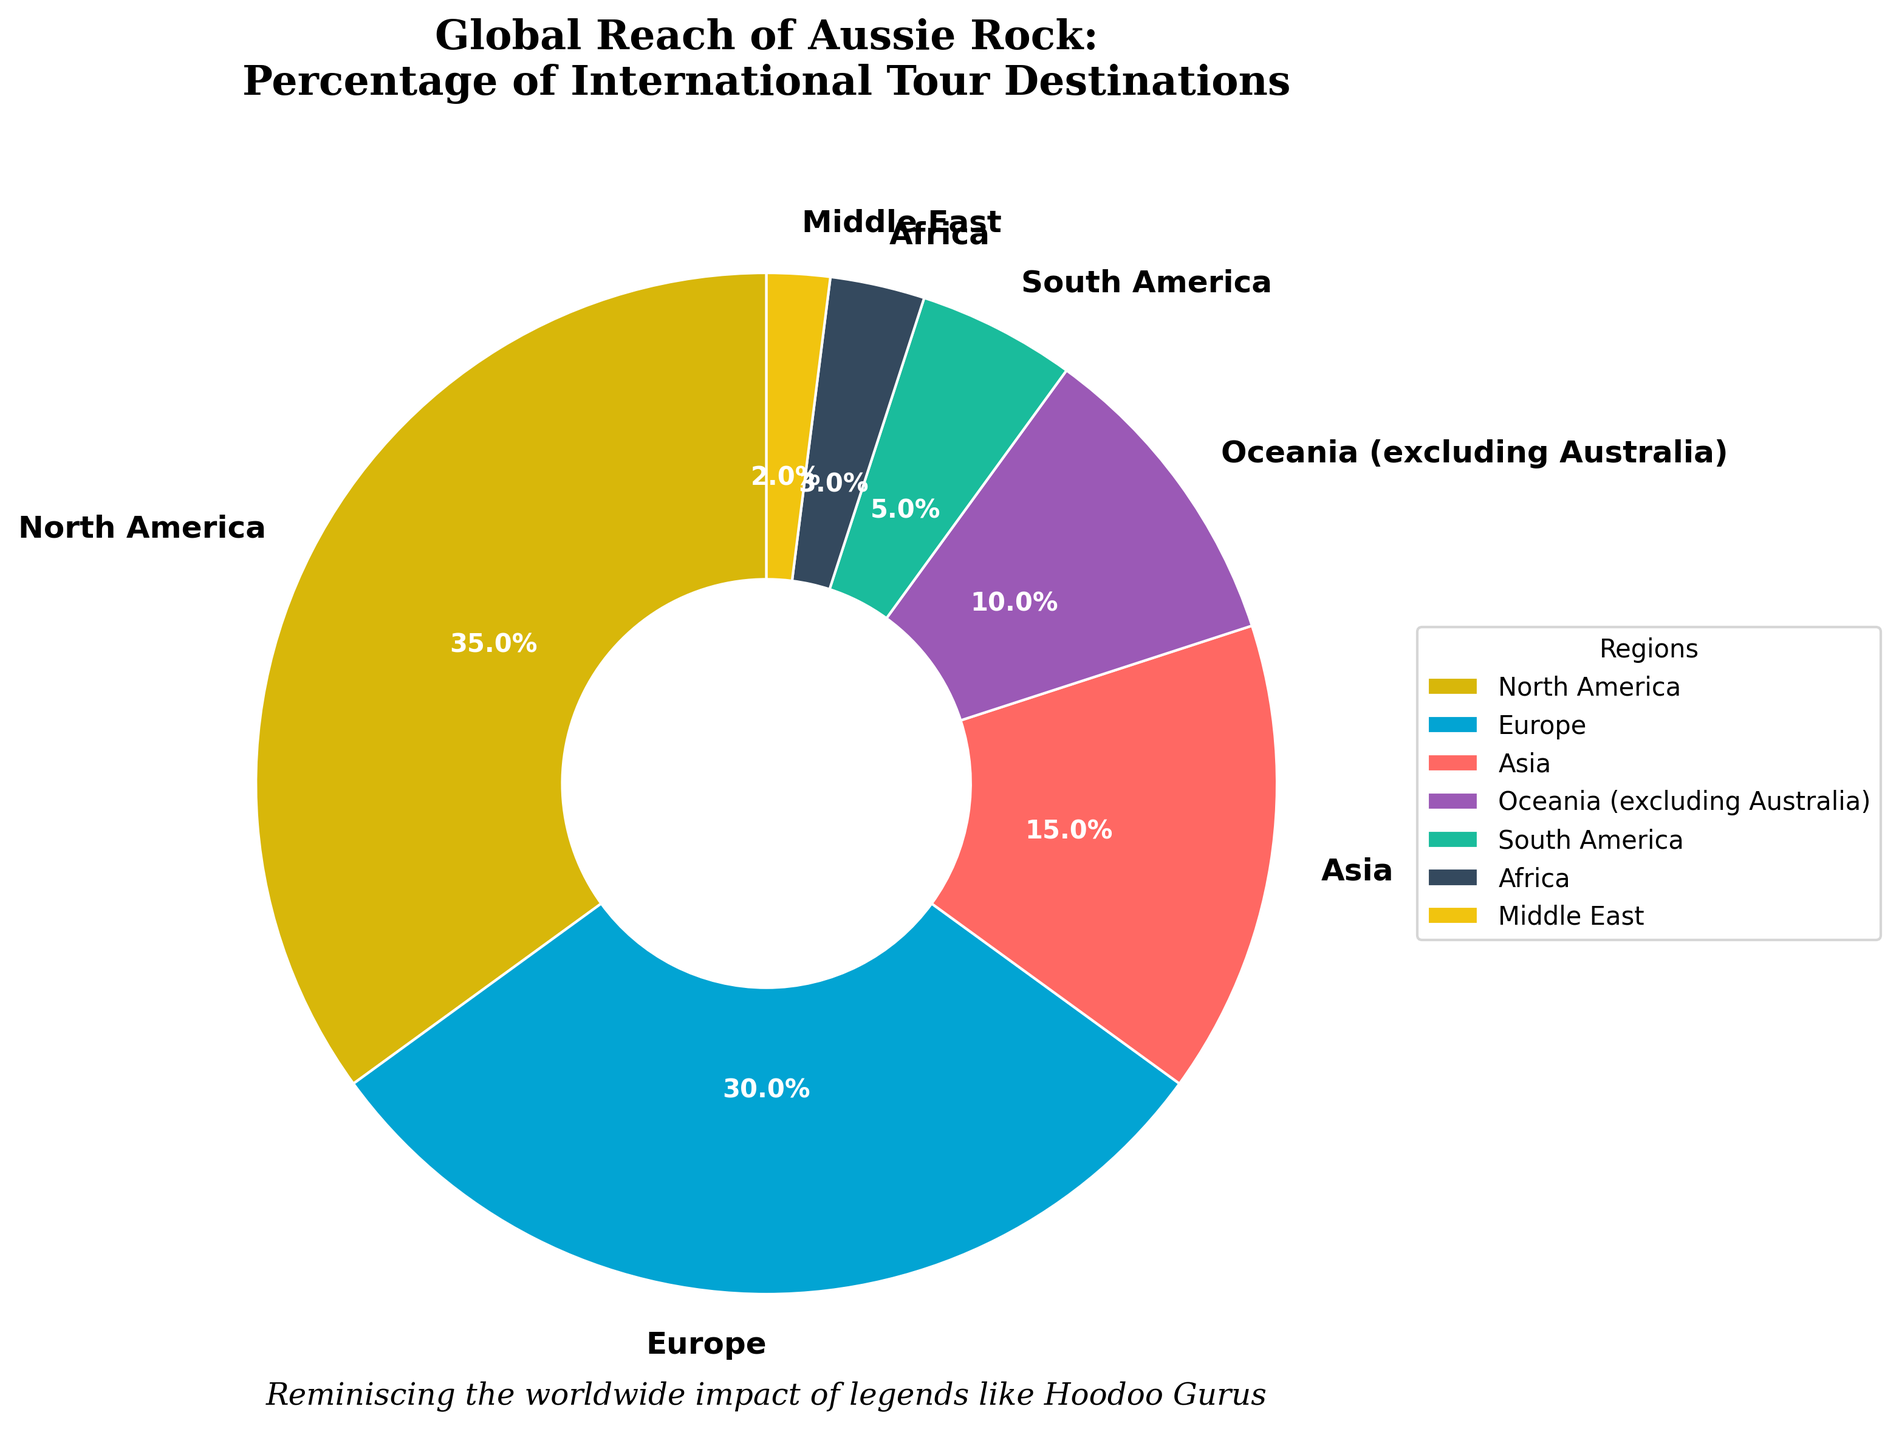Which region has the highest percentage of international tour destinations? North America is highlighted as the region with the highest percentage, indicated in the chart as having the largest wedge size, representing 35%.
Answer: North America What is the combined percentage of international tour destinations in South America and Africa? The chart shows that South America has 5% and Africa has 3%. Adding them together, 5% + 3% = 8%.
Answer: 8% How does Europe compare to Oceania (excluding Australia) in terms of percentage of international tour destinations? Europe has 30% of the international tour destinations, while Oceania (excluding Australia) has 10%. Europe has a higher percentage.
Answer: Europe has a higher percentage Which region has the smallest percentage of international tour destinations? The chart highlights that the Middle East, with 2%, has the smallest percentage of international tour destinations.
Answer: Middle East What percentage more tour destinations does North America have compared to Asia? North America has 35%, and Asia has 15%. The difference in percentage points is 35% - 15% = 20%.
Answer: 20% What fraction of the tour destinations are in Europe and North America combined? Europe has 30% and North America has 35%. Adding them together gives 30% + 35% = 65%. Converting this to a fraction, 65% = 65/100 = 13/20.
Answer: 13/20 How many regions have a percentage of international tour destinations greater than 10%? The regions with percentages greater than 10% are North America (35%), Europe (30%), and Asia (15%). Three regions in total.
Answer: 3 If you had to divide regions into those with more than 10% of international tour destinations and those with 10% or less, how many regions would be in each category? Regions with more than 10% are North America (35%), Europe (30%), and Asia (15%). Regions with 10% or less are Oceania excluding Australia (10%), South America (5%), Africa (3%), and Middle East (2%). Thus, there are 3 regions with more than 10% and 4 regions with 10% or less.
Answer: 3 regions with more than 10%, 4 regions with 10% or less 